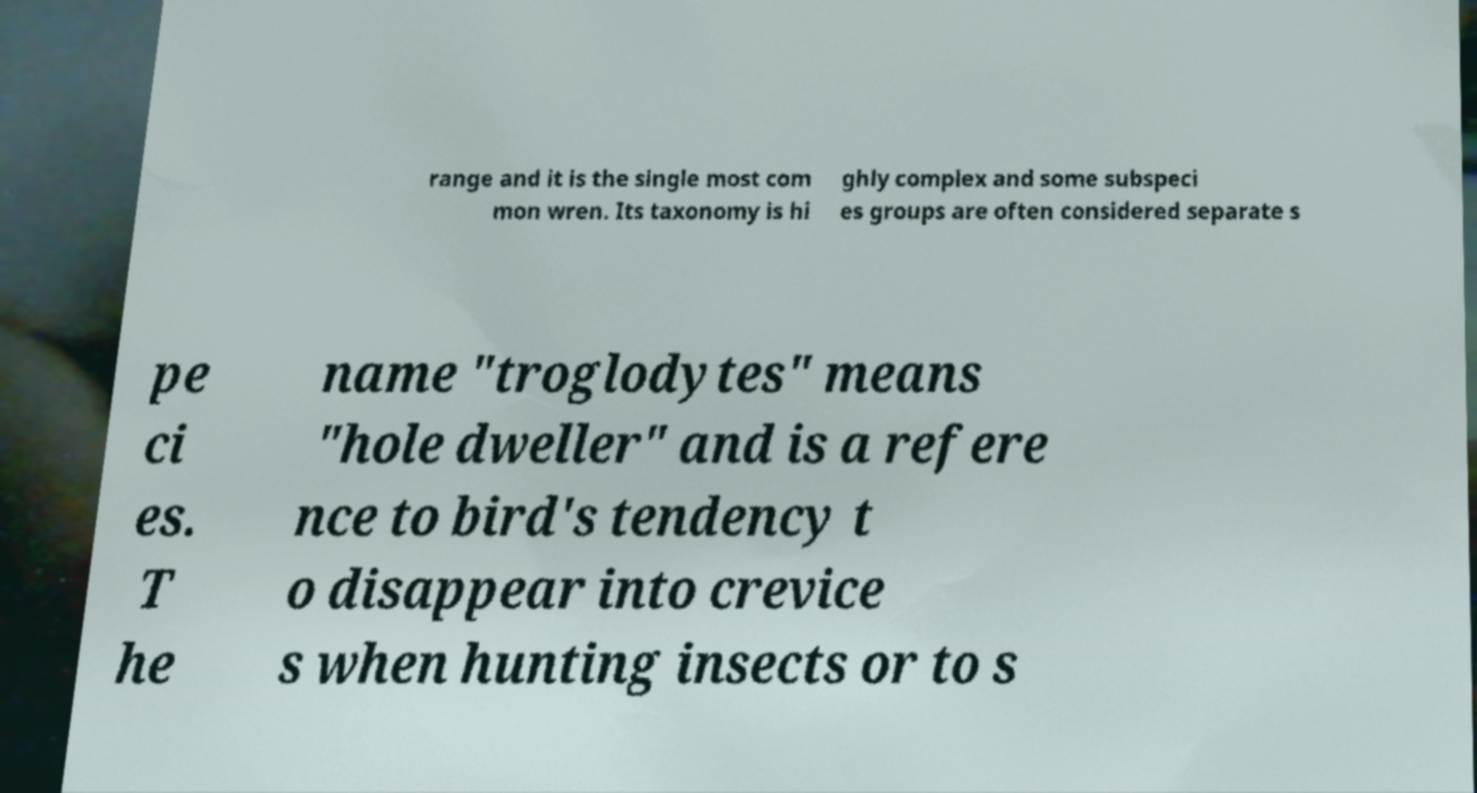I need the written content from this picture converted into text. Can you do that? range and it is the single most com mon wren. Its taxonomy is hi ghly complex and some subspeci es groups are often considered separate s pe ci es. T he name "troglodytes" means "hole dweller" and is a refere nce to bird's tendency t o disappear into crevice s when hunting insects or to s 